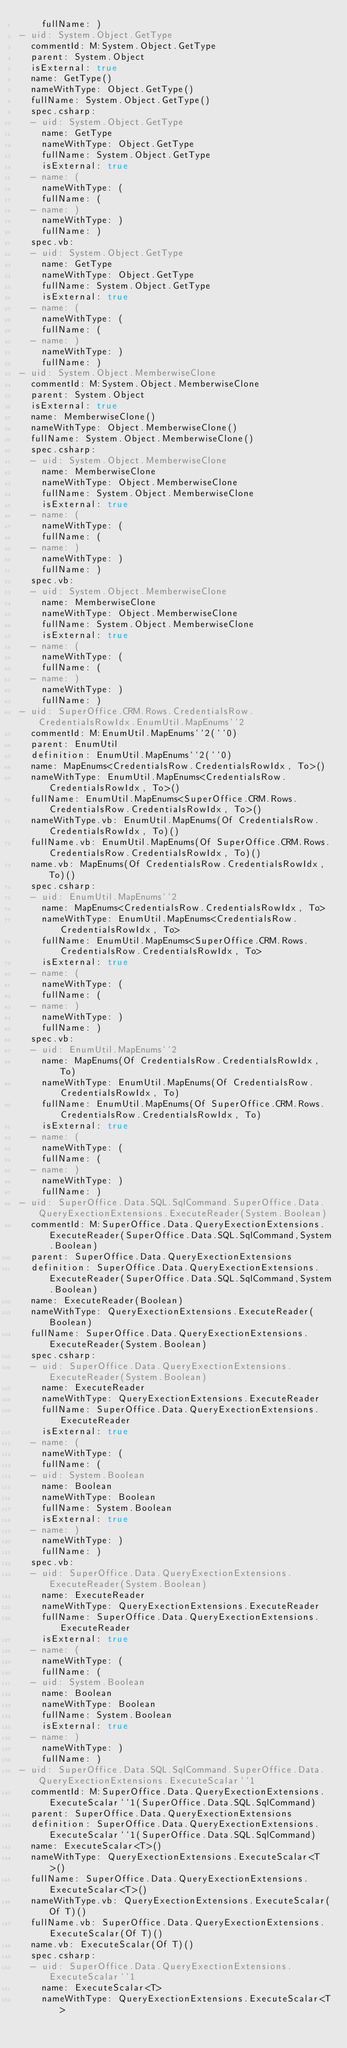Convert code to text. <code><loc_0><loc_0><loc_500><loc_500><_YAML_>    fullName: )
- uid: System.Object.GetType
  commentId: M:System.Object.GetType
  parent: System.Object
  isExternal: true
  name: GetType()
  nameWithType: Object.GetType()
  fullName: System.Object.GetType()
  spec.csharp:
  - uid: System.Object.GetType
    name: GetType
    nameWithType: Object.GetType
    fullName: System.Object.GetType
    isExternal: true
  - name: (
    nameWithType: (
    fullName: (
  - name: )
    nameWithType: )
    fullName: )
  spec.vb:
  - uid: System.Object.GetType
    name: GetType
    nameWithType: Object.GetType
    fullName: System.Object.GetType
    isExternal: true
  - name: (
    nameWithType: (
    fullName: (
  - name: )
    nameWithType: )
    fullName: )
- uid: System.Object.MemberwiseClone
  commentId: M:System.Object.MemberwiseClone
  parent: System.Object
  isExternal: true
  name: MemberwiseClone()
  nameWithType: Object.MemberwiseClone()
  fullName: System.Object.MemberwiseClone()
  spec.csharp:
  - uid: System.Object.MemberwiseClone
    name: MemberwiseClone
    nameWithType: Object.MemberwiseClone
    fullName: System.Object.MemberwiseClone
    isExternal: true
  - name: (
    nameWithType: (
    fullName: (
  - name: )
    nameWithType: )
    fullName: )
  spec.vb:
  - uid: System.Object.MemberwiseClone
    name: MemberwiseClone
    nameWithType: Object.MemberwiseClone
    fullName: System.Object.MemberwiseClone
    isExternal: true
  - name: (
    nameWithType: (
    fullName: (
  - name: )
    nameWithType: )
    fullName: )
- uid: SuperOffice.CRM.Rows.CredentialsRow.CredentialsRowIdx.EnumUtil.MapEnums``2
  commentId: M:EnumUtil.MapEnums``2(``0)
  parent: EnumUtil
  definition: EnumUtil.MapEnums``2(``0)
  name: MapEnums<CredentialsRow.CredentialsRowIdx, To>()
  nameWithType: EnumUtil.MapEnums<CredentialsRow.CredentialsRowIdx, To>()
  fullName: EnumUtil.MapEnums<SuperOffice.CRM.Rows.CredentialsRow.CredentialsRowIdx, To>()
  nameWithType.vb: EnumUtil.MapEnums(Of CredentialsRow.CredentialsRowIdx, To)()
  fullName.vb: EnumUtil.MapEnums(Of SuperOffice.CRM.Rows.CredentialsRow.CredentialsRowIdx, To)()
  name.vb: MapEnums(Of CredentialsRow.CredentialsRowIdx, To)()
  spec.csharp:
  - uid: EnumUtil.MapEnums``2
    name: MapEnums<CredentialsRow.CredentialsRowIdx, To>
    nameWithType: EnumUtil.MapEnums<CredentialsRow.CredentialsRowIdx, To>
    fullName: EnumUtil.MapEnums<SuperOffice.CRM.Rows.CredentialsRow.CredentialsRowIdx, To>
    isExternal: true
  - name: (
    nameWithType: (
    fullName: (
  - name: )
    nameWithType: )
    fullName: )
  spec.vb:
  - uid: EnumUtil.MapEnums``2
    name: MapEnums(Of CredentialsRow.CredentialsRowIdx, To)
    nameWithType: EnumUtil.MapEnums(Of CredentialsRow.CredentialsRowIdx, To)
    fullName: EnumUtil.MapEnums(Of SuperOffice.CRM.Rows.CredentialsRow.CredentialsRowIdx, To)
    isExternal: true
  - name: (
    nameWithType: (
    fullName: (
  - name: )
    nameWithType: )
    fullName: )
- uid: SuperOffice.Data.SQL.SqlCommand.SuperOffice.Data.QueryExectionExtensions.ExecuteReader(System.Boolean)
  commentId: M:SuperOffice.Data.QueryExectionExtensions.ExecuteReader(SuperOffice.Data.SQL.SqlCommand,System.Boolean)
  parent: SuperOffice.Data.QueryExectionExtensions
  definition: SuperOffice.Data.QueryExectionExtensions.ExecuteReader(SuperOffice.Data.SQL.SqlCommand,System.Boolean)
  name: ExecuteReader(Boolean)
  nameWithType: QueryExectionExtensions.ExecuteReader(Boolean)
  fullName: SuperOffice.Data.QueryExectionExtensions.ExecuteReader(System.Boolean)
  spec.csharp:
  - uid: SuperOffice.Data.QueryExectionExtensions.ExecuteReader(System.Boolean)
    name: ExecuteReader
    nameWithType: QueryExectionExtensions.ExecuteReader
    fullName: SuperOffice.Data.QueryExectionExtensions.ExecuteReader
    isExternal: true
  - name: (
    nameWithType: (
    fullName: (
  - uid: System.Boolean
    name: Boolean
    nameWithType: Boolean
    fullName: System.Boolean
    isExternal: true
  - name: )
    nameWithType: )
    fullName: )
  spec.vb:
  - uid: SuperOffice.Data.QueryExectionExtensions.ExecuteReader(System.Boolean)
    name: ExecuteReader
    nameWithType: QueryExectionExtensions.ExecuteReader
    fullName: SuperOffice.Data.QueryExectionExtensions.ExecuteReader
    isExternal: true
  - name: (
    nameWithType: (
    fullName: (
  - uid: System.Boolean
    name: Boolean
    nameWithType: Boolean
    fullName: System.Boolean
    isExternal: true
  - name: )
    nameWithType: )
    fullName: )
- uid: SuperOffice.Data.SQL.SqlCommand.SuperOffice.Data.QueryExectionExtensions.ExecuteScalar``1
  commentId: M:SuperOffice.Data.QueryExectionExtensions.ExecuteScalar``1(SuperOffice.Data.SQL.SqlCommand)
  parent: SuperOffice.Data.QueryExectionExtensions
  definition: SuperOffice.Data.QueryExectionExtensions.ExecuteScalar``1(SuperOffice.Data.SQL.SqlCommand)
  name: ExecuteScalar<T>()
  nameWithType: QueryExectionExtensions.ExecuteScalar<T>()
  fullName: SuperOffice.Data.QueryExectionExtensions.ExecuteScalar<T>()
  nameWithType.vb: QueryExectionExtensions.ExecuteScalar(Of T)()
  fullName.vb: SuperOffice.Data.QueryExectionExtensions.ExecuteScalar(Of T)()
  name.vb: ExecuteScalar(Of T)()
  spec.csharp:
  - uid: SuperOffice.Data.QueryExectionExtensions.ExecuteScalar``1
    name: ExecuteScalar<T>
    nameWithType: QueryExectionExtensions.ExecuteScalar<T></code> 